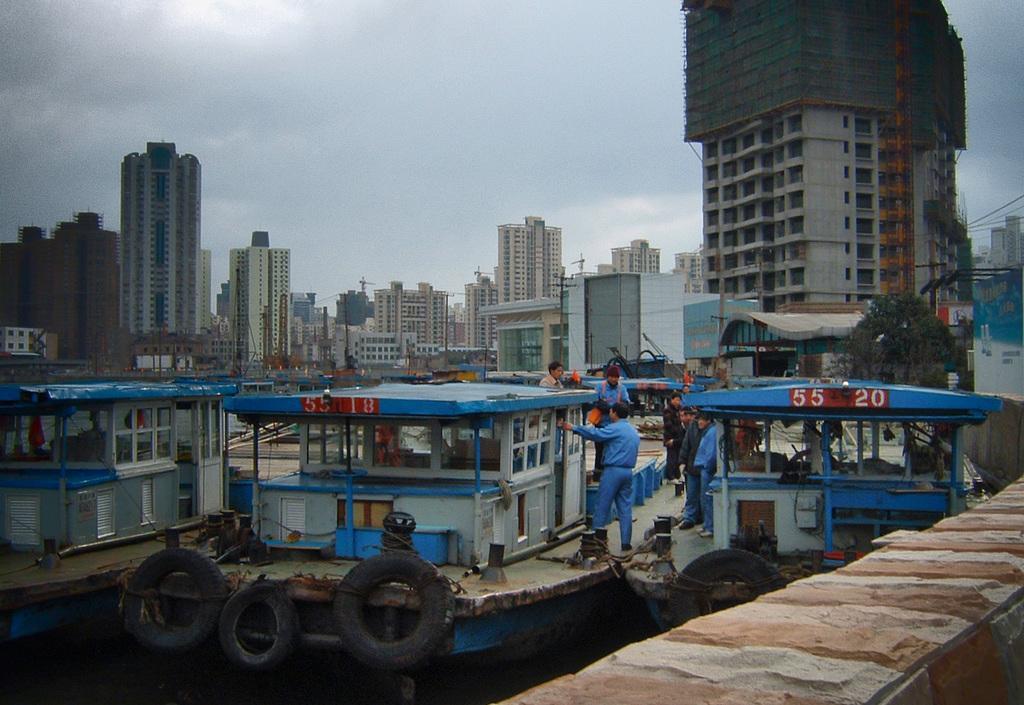Can you describe this image briefly? In this image I can see tyres, boats, people and number of buildings and in the background there is sky. 